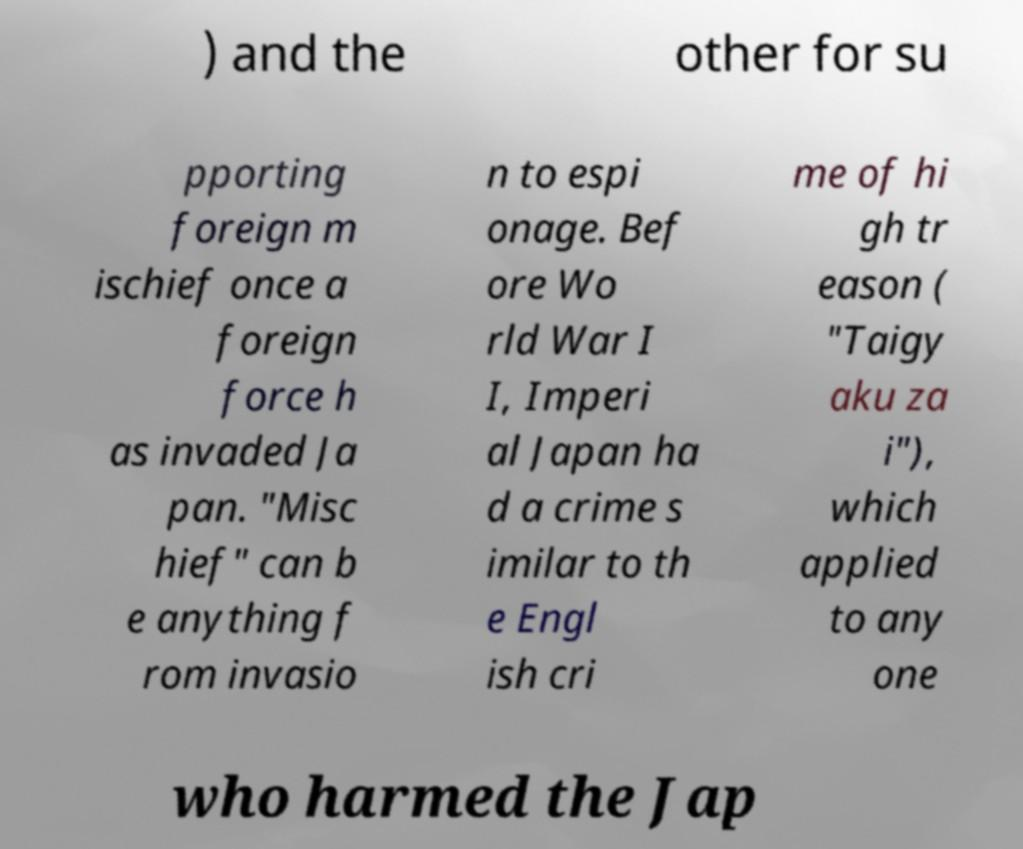Please identify and transcribe the text found in this image. ) and the other for su pporting foreign m ischief once a foreign force h as invaded Ja pan. "Misc hief" can b e anything f rom invasio n to espi onage. Bef ore Wo rld War I I, Imperi al Japan ha d a crime s imilar to th e Engl ish cri me of hi gh tr eason ( "Taigy aku za i"), which applied to any one who harmed the Jap 